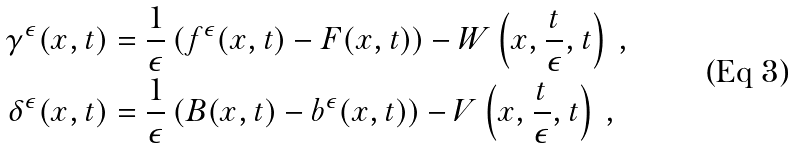Convert formula to latex. <formula><loc_0><loc_0><loc_500><loc_500>\gamma ^ { \epsilon } ( x , t ) & = \frac { 1 } { \epsilon } \left ( f ^ { \epsilon } ( x , t ) - F ( x , t ) \right ) - W \left ( x , \frac { t } { \epsilon } , t \right ) \, , \\ \delta ^ { \epsilon } ( x , t ) & = \frac { 1 } { \epsilon } \left ( B ( x , t ) - b ^ { \epsilon } ( x , t ) \right ) - V \left ( x , \frac { t } { \epsilon } , t \right ) \, ,</formula> 